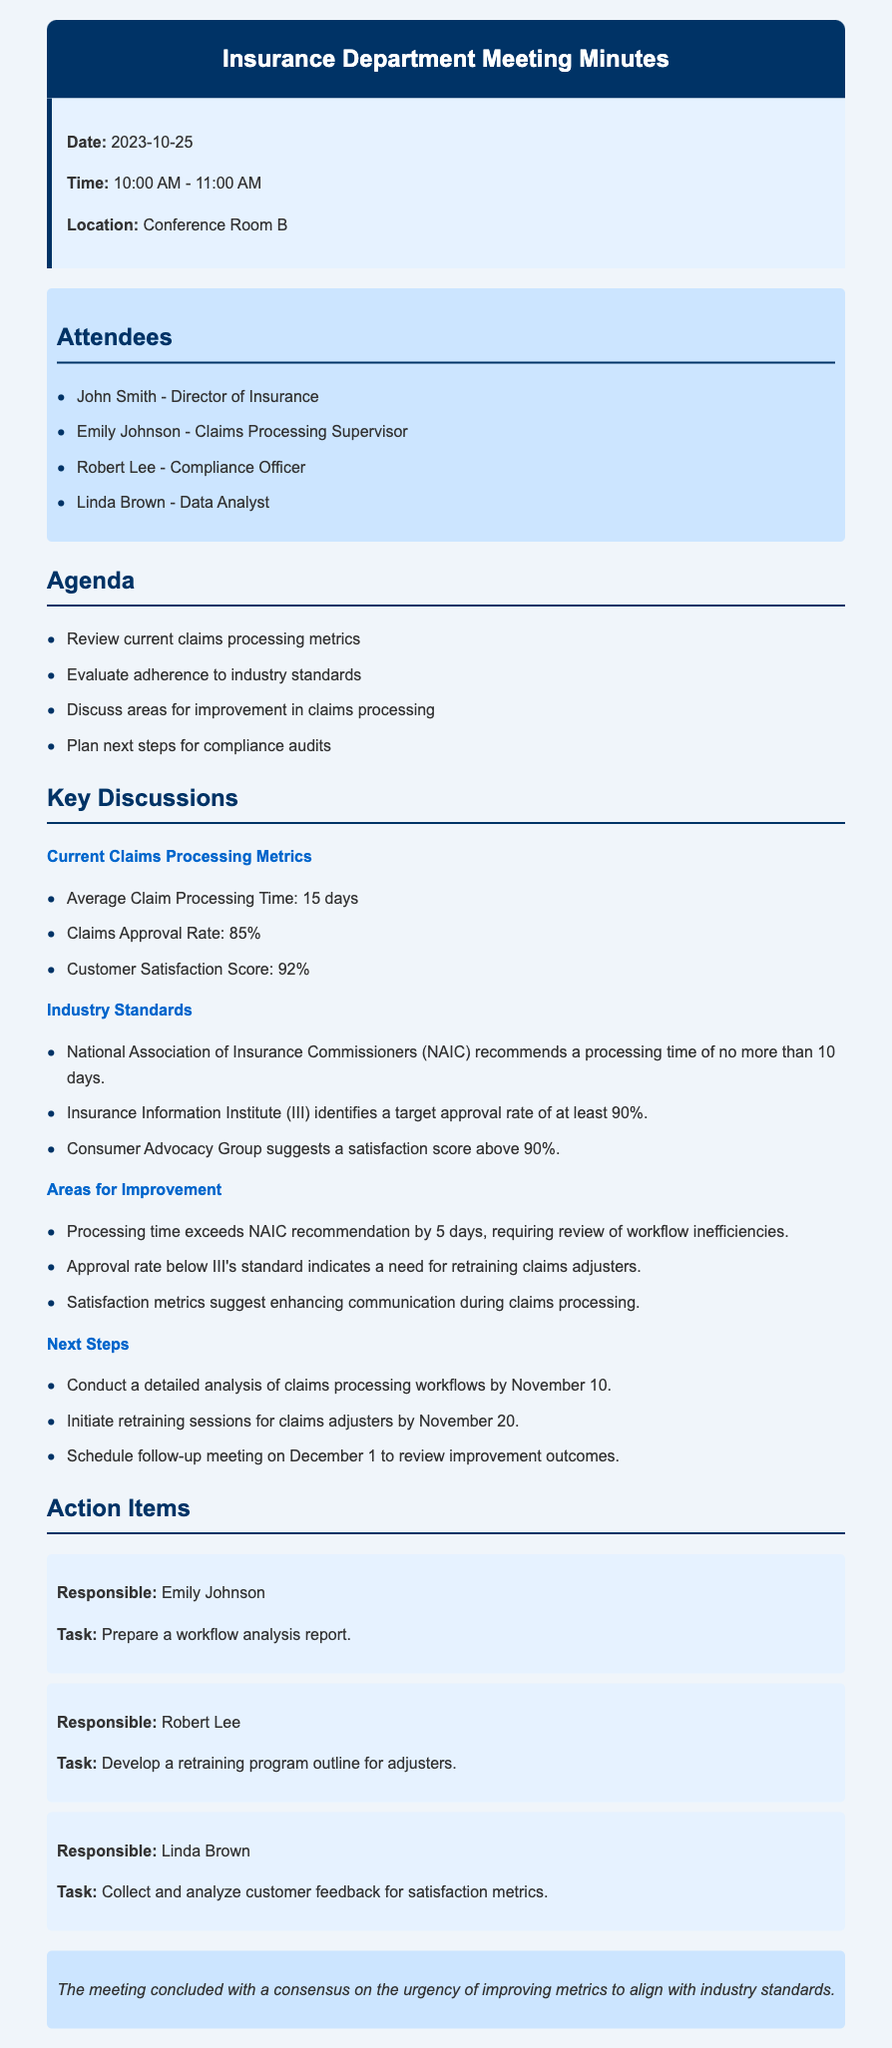what is the date of the meeting? The date of the meeting is provided in the document under meeting info section.
Answer: 2023-10-25 who is the Director of Insurance? The name of the Director of Insurance is listed among the attendees.
Answer: John Smith what is the average claim processing time? The average claim processing time is stated under the current claims processing metrics.
Answer: 15 days what is the claims approval rate target by III? The target approval rate by III is mentioned in the industry standards section.
Answer: at least 90% by how many days does the processing time exceed NAIC's recommendation? The document specifies how much the processing time exceeds the recommended standard.
Answer: 5 days what is the customer satisfaction score reported? The customer satisfaction score can be found in the key discussions section.
Answer: 92% who is responsible for preparing the workflow analysis report? The individual responsible for the workflow analysis report is mentioned under action items.
Answer: Emily Johnson when is the follow-up meeting scheduled to review improvement outcomes? The date for the follow-up meeting is indicated in the next steps section.
Answer: December 1 what is the main consensus at the conclusion of the meeting? The document includes a statement about the consensus reached at the conclusion of the meeting.
Answer: urgency of improving metrics to align with industry standards 